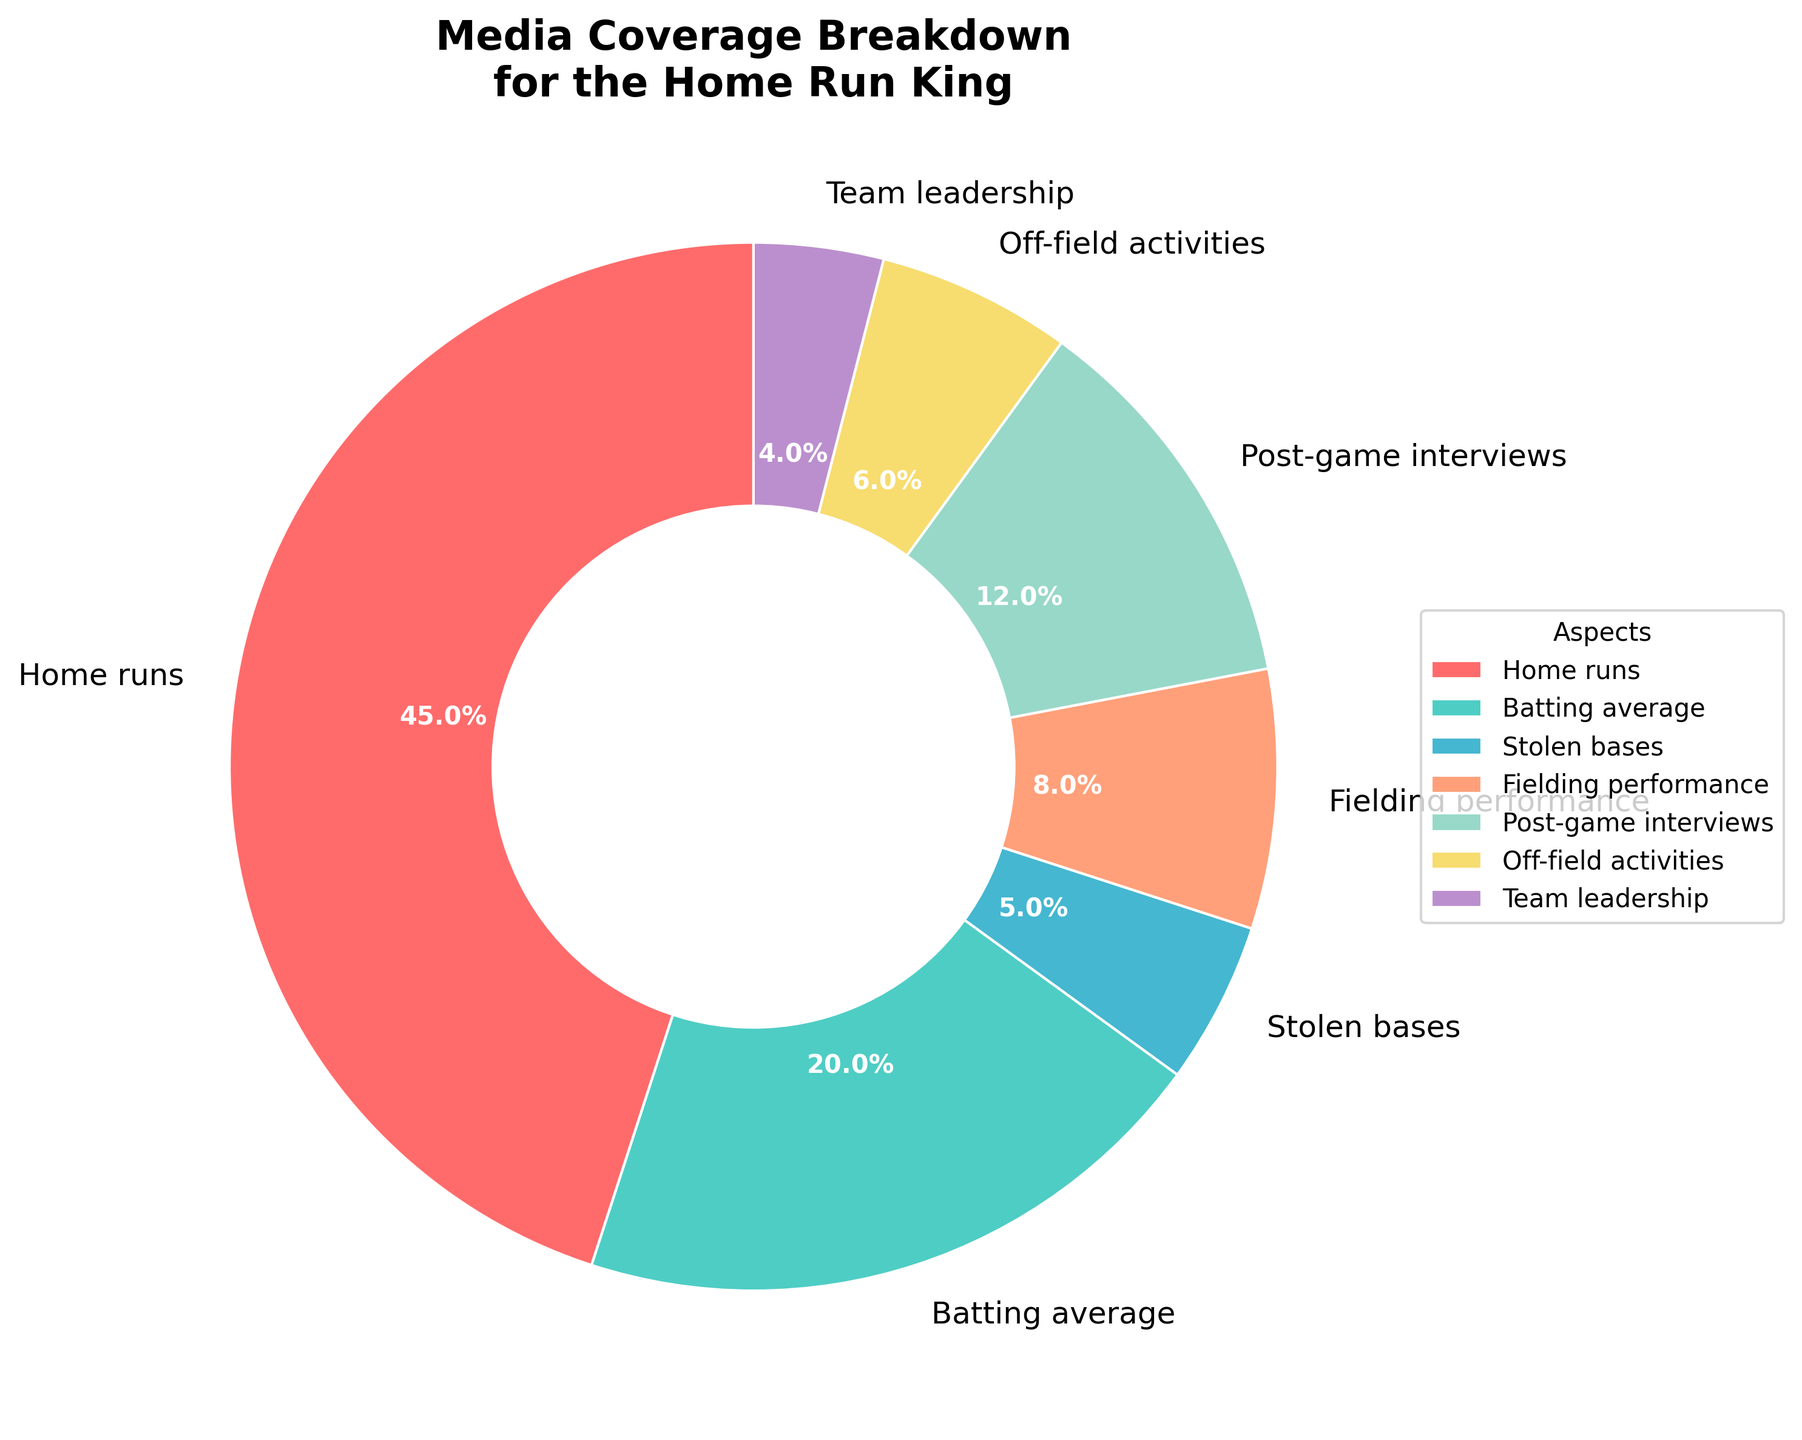What aspect of the player's performance has the highest media coverage? The pie chart shows the proportions of media coverage for various aspects of the player's performance. Home runs occupy the largest segment of the chart.
Answer: Home runs How many percentage points more coverage is given to home runs than to post-game interviews? The pie chart shows that home runs receive 45% and post-game interviews receive 12%. The difference is calculated as 45% - 12%.
Answer: 33% Which two aspects have the smallest media coverage, and what is their combined percentage? The pie chart shows the different segments for each aspect. The smallest segments are for team leadership (4%) and stolen bases (5%). Their combined percentage is 4% + 5%.
Answer: Team leadership and stolen bases, 9% What percentage of media coverage is given to performance-related aspects (home runs, batting average, stolen bases, fielding performance)? The pie chart lists the percentages for home runs (45%), batting average (20%), stolen bases (5%), and fielding performance (8%). Summing these gives 45% + 20% + 5% + 8%.
Answer: 78% Which aspect is represented by the light green segment in the pie chart? Looking at the pie chart, the light green color corresponds to off-field activities.
Answer: Off-field activities By how many percentage points does the batting average coverage exceed team leadership coverage? The chart shows batting average has 20% coverage and team leadership has 4% coverage. The difference is 20% - 4%.
Answer: 16% Which aspect has a percentage coverage closest to 10%? The pie chart shows various segments with their percentages. Post-game interviews, which have 12%, are closest to 10%.
Answer: Post-game interviews Is the percentage of media coverage for fielding performance higher or lower than that for off-field activities? Comparing the pie chart segments, fielding performance has 8% and off-field activities have 6%.
Answer: Higher What is the percentage difference between the coverage of fielding performance and stolen bases? The chart shows fielding performance at 8% and stolen bases at 5%. The difference is 8% - 5%.
Answer: 3% Are the home runs and batting average segments together more than half of the total media coverage? The chart shows home runs at 45% and batting average at 20%. Their combined percentage is 45% + 20%. This is notably more than 50%.
Answer: Yes 